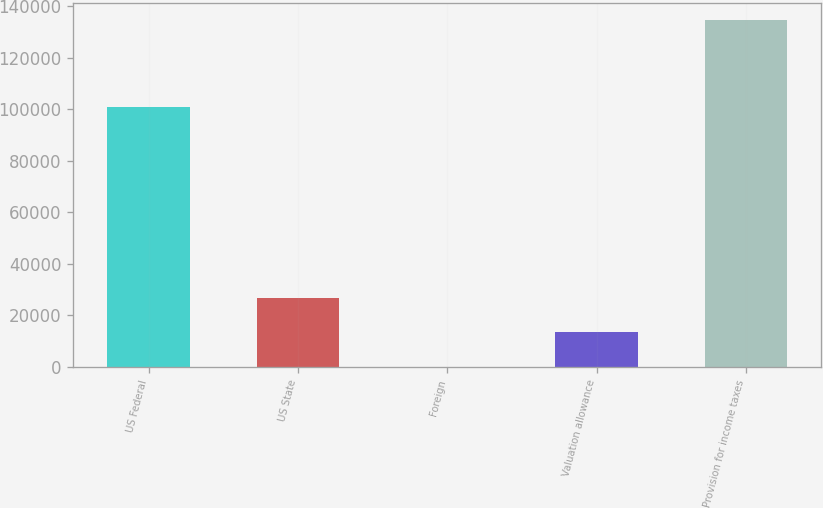Convert chart. <chart><loc_0><loc_0><loc_500><loc_500><bar_chart><fcel>US Federal<fcel>US State<fcel>Foreign<fcel>Valuation allowance<fcel>Provision for income taxes<nl><fcel>100983<fcel>26956.8<fcel>6<fcel>13481.4<fcel>134760<nl></chart> 